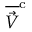<formula> <loc_0><loc_0><loc_500><loc_500>\overline { { \vec { V } } } ^ { c }</formula> 